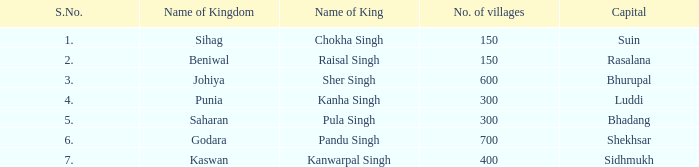What monarchy has suin as its chief city? Sihag. 